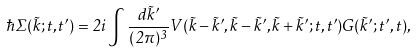<formula> <loc_0><loc_0><loc_500><loc_500>\hbar { \Sigma } ( \vec { k } ; t , t ^ { \prime } ) = 2 i \int \frac { d \vec { k } ^ { \prime } } { ( 2 \pi ) ^ { 3 } } V ( \vec { k } - \vec { k } ^ { \prime } , \vec { k } - \vec { k } ^ { \prime } , \vec { k } + \vec { k } ^ { \prime } ; t , t ^ { \prime } ) G ( \vec { k } ^ { \prime } ; t ^ { \prime } , t ) ,</formula> 